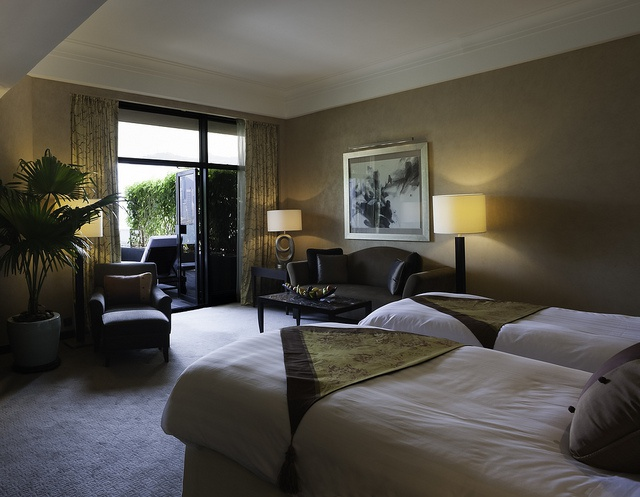Describe the objects in this image and their specific colors. I can see bed in gray and black tones, potted plant in gray, black, and olive tones, bed in gray and black tones, chair in gray, black, and darkgray tones, and couch in gray, black, and lavender tones in this image. 